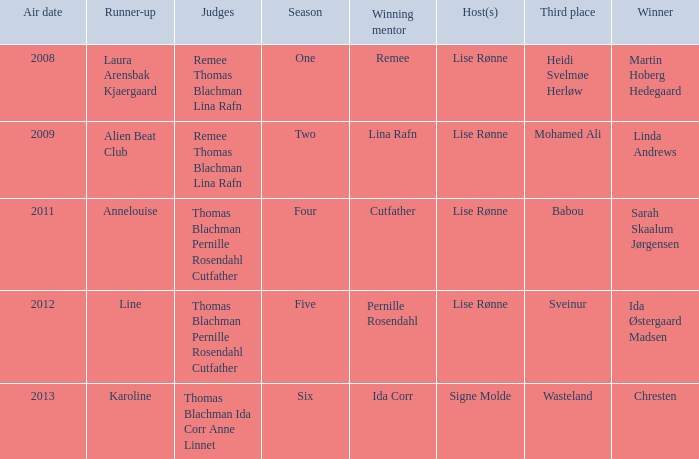Who was the runner-up in season five? Line. 